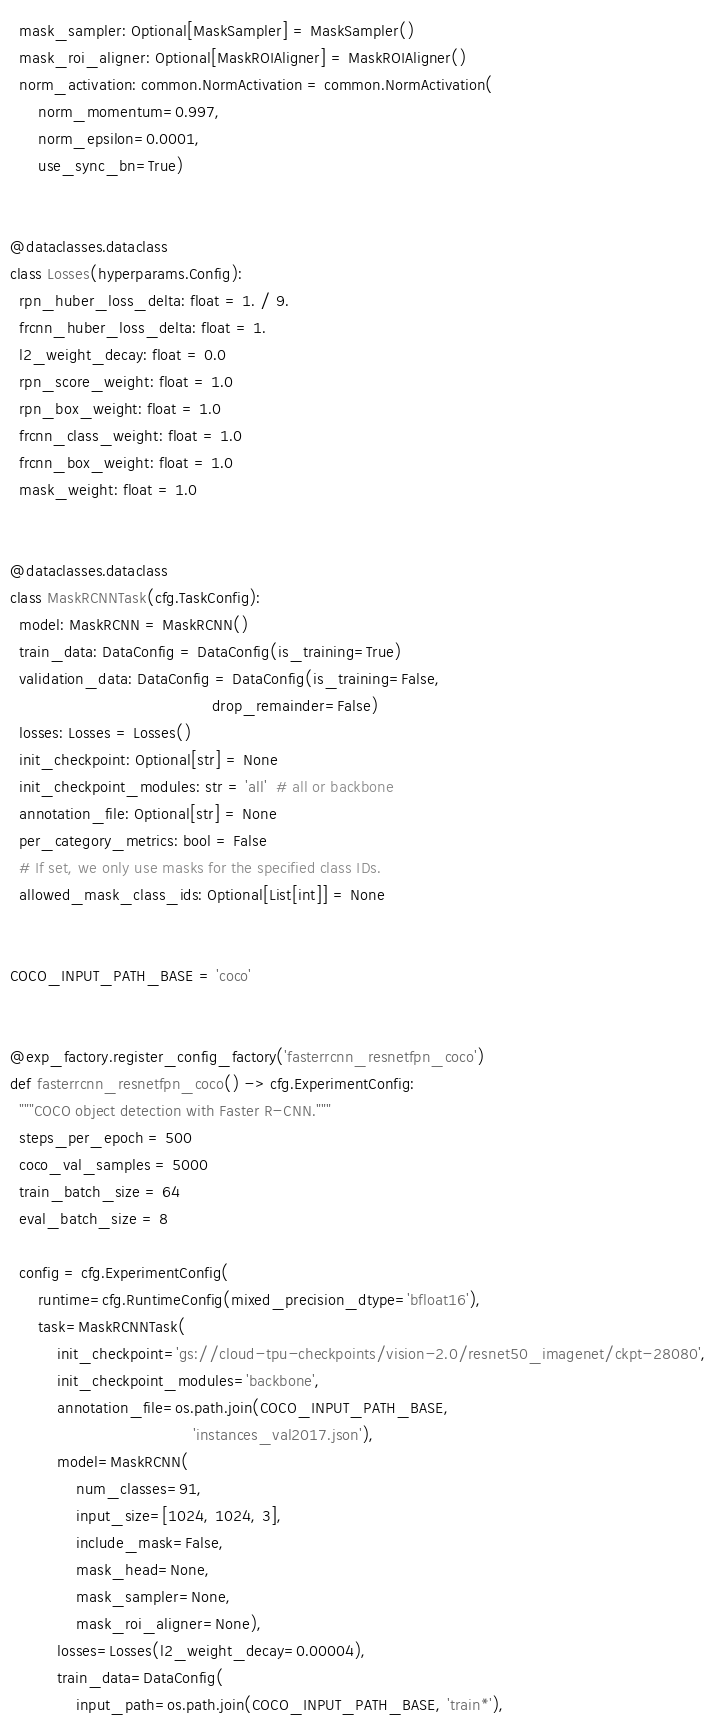<code> <loc_0><loc_0><loc_500><loc_500><_Python_>  mask_sampler: Optional[MaskSampler] = MaskSampler()
  mask_roi_aligner: Optional[MaskROIAligner] = MaskROIAligner()
  norm_activation: common.NormActivation = common.NormActivation(
      norm_momentum=0.997,
      norm_epsilon=0.0001,
      use_sync_bn=True)


@dataclasses.dataclass
class Losses(hyperparams.Config):
  rpn_huber_loss_delta: float = 1. / 9.
  frcnn_huber_loss_delta: float = 1.
  l2_weight_decay: float = 0.0
  rpn_score_weight: float = 1.0
  rpn_box_weight: float = 1.0
  frcnn_class_weight: float = 1.0
  frcnn_box_weight: float = 1.0
  mask_weight: float = 1.0


@dataclasses.dataclass
class MaskRCNNTask(cfg.TaskConfig):
  model: MaskRCNN = MaskRCNN()
  train_data: DataConfig = DataConfig(is_training=True)
  validation_data: DataConfig = DataConfig(is_training=False,
                                           drop_remainder=False)
  losses: Losses = Losses()
  init_checkpoint: Optional[str] = None
  init_checkpoint_modules: str = 'all'  # all or backbone
  annotation_file: Optional[str] = None
  per_category_metrics: bool = False
  # If set, we only use masks for the specified class IDs.
  allowed_mask_class_ids: Optional[List[int]] = None


COCO_INPUT_PATH_BASE = 'coco'


@exp_factory.register_config_factory('fasterrcnn_resnetfpn_coco')
def fasterrcnn_resnetfpn_coco() -> cfg.ExperimentConfig:
  """COCO object detection with Faster R-CNN."""
  steps_per_epoch = 500
  coco_val_samples = 5000
  train_batch_size = 64
  eval_batch_size = 8

  config = cfg.ExperimentConfig(
      runtime=cfg.RuntimeConfig(mixed_precision_dtype='bfloat16'),
      task=MaskRCNNTask(
          init_checkpoint='gs://cloud-tpu-checkpoints/vision-2.0/resnet50_imagenet/ckpt-28080',
          init_checkpoint_modules='backbone',
          annotation_file=os.path.join(COCO_INPUT_PATH_BASE,
                                       'instances_val2017.json'),
          model=MaskRCNN(
              num_classes=91,
              input_size=[1024, 1024, 3],
              include_mask=False,
              mask_head=None,
              mask_sampler=None,
              mask_roi_aligner=None),
          losses=Losses(l2_weight_decay=0.00004),
          train_data=DataConfig(
              input_path=os.path.join(COCO_INPUT_PATH_BASE, 'train*'),</code> 